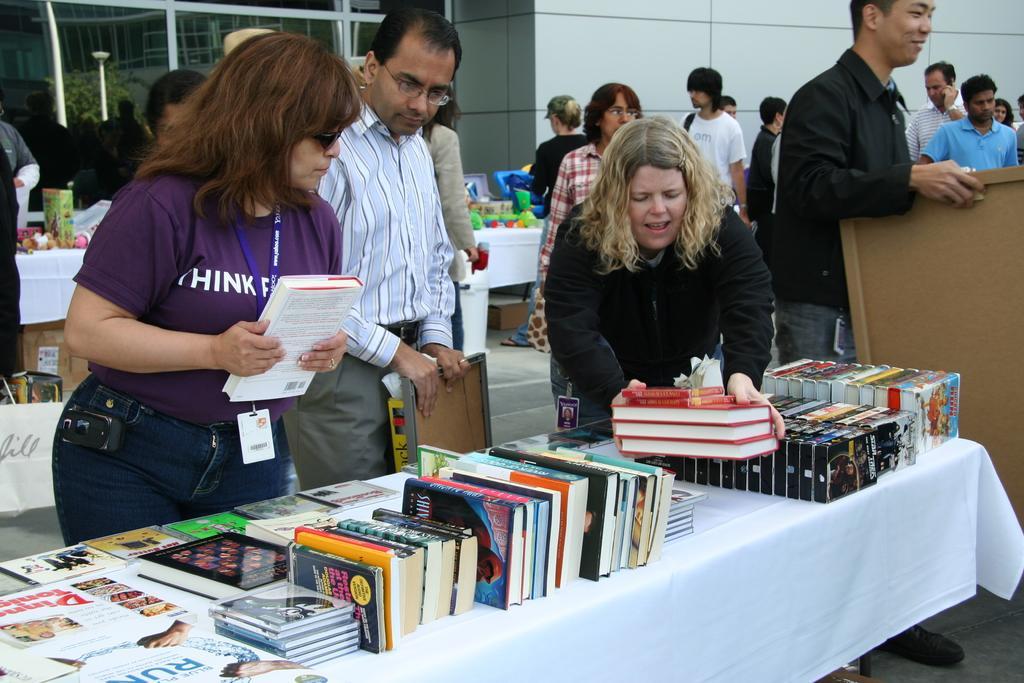In one or two sentences, can you explain what this image depicts? In this image there are some persons are standing in middle of this image and the person is at left side of this image is holding book and there is a table at bottom of this image and there are some books are kept on it. There is a building in the background and there are some glass doors at top left corner of this image and there is an another table is at left side of this image and there are some objects kept on it. 